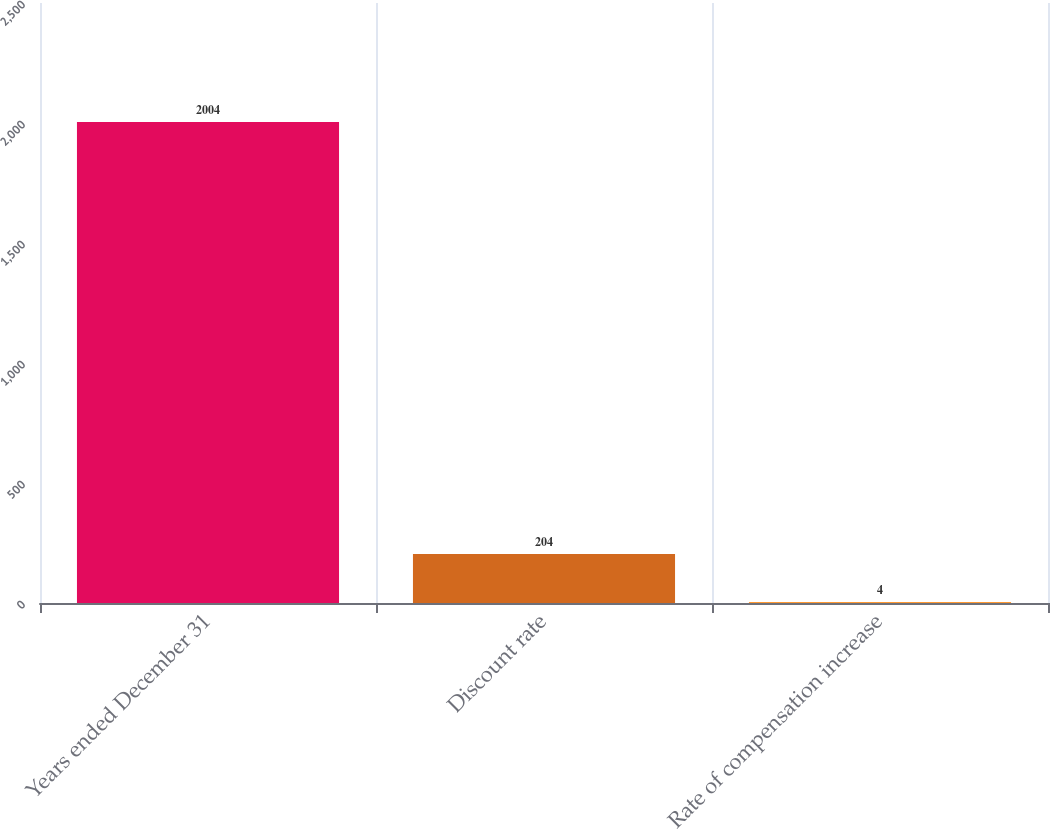<chart> <loc_0><loc_0><loc_500><loc_500><bar_chart><fcel>Years ended December 31<fcel>Discount rate<fcel>Rate of compensation increase<nl><fcel>2004<fcel>204<fcel>4<nl></chart> 